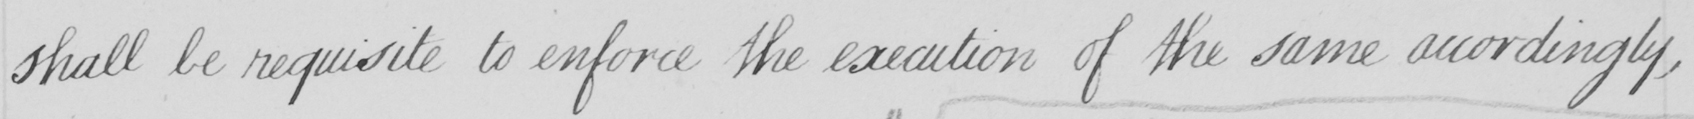Transcribe the text shown in this historical manuscript line. shall be requisite to enforce the execution of the same accordingly , 